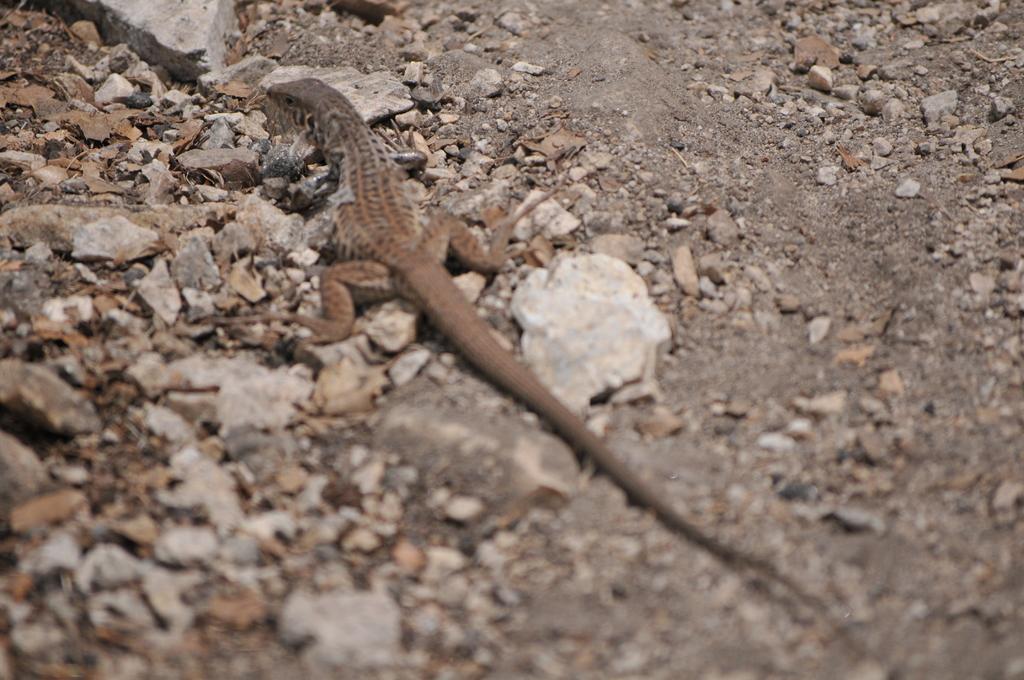Could you give a brief overview of what you see in this image? In this image we can see a lizard is sitting on the ground. And we can see dry leaves and stones. 